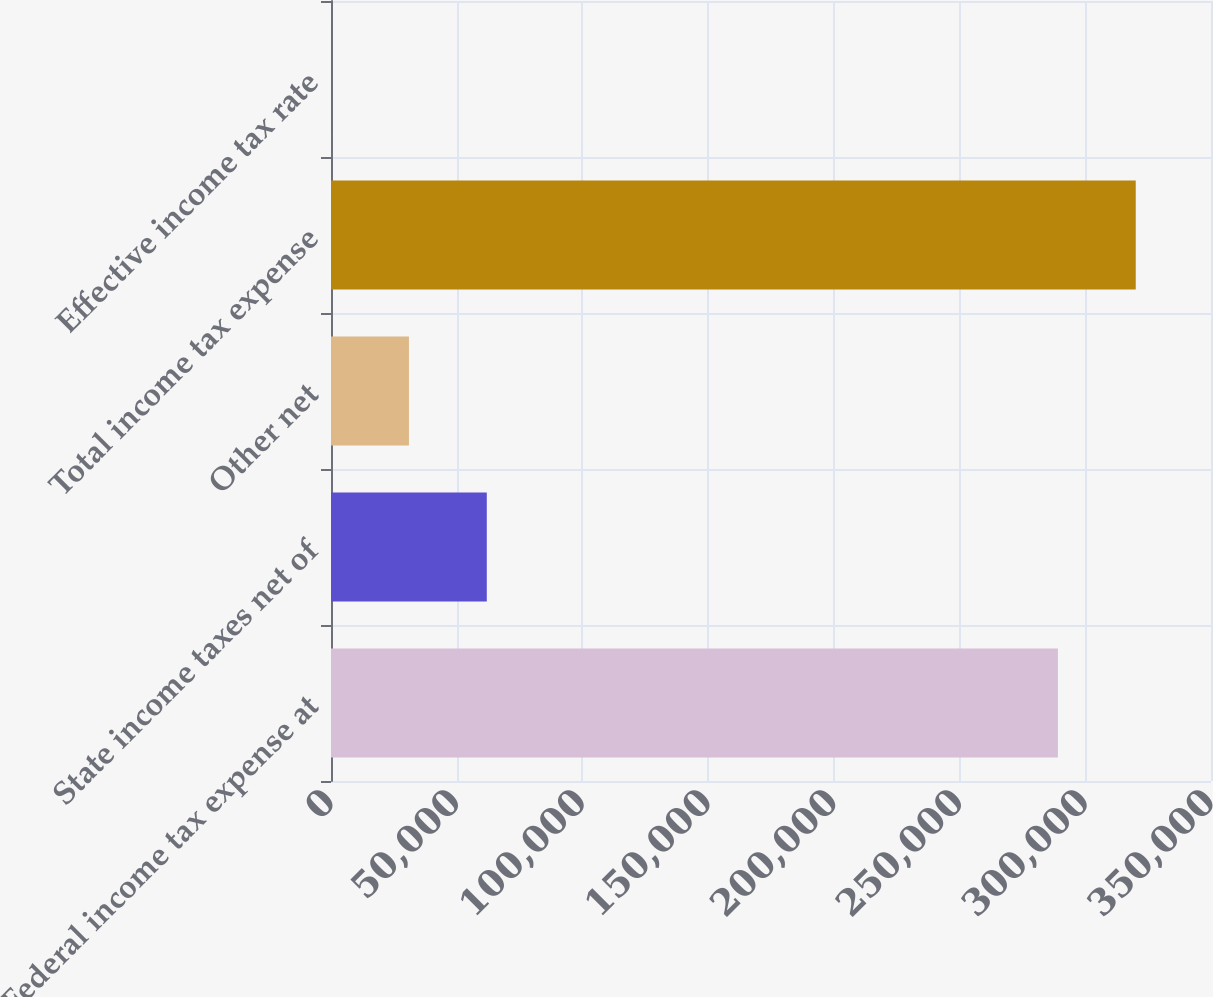<chart> <loc_0><loc_0><loc_500><loc_500><bar_chart><fcel>Federal income tax expense at<fcel>State income taxes net of<fcel>Other net<fcel>Total income tax expense<fcel>Effective income tax rate<nl><fcel>289107<fcel>61961.8<fcel>30999.7<fcel>320069<fcel>37.5<nl></chart> 